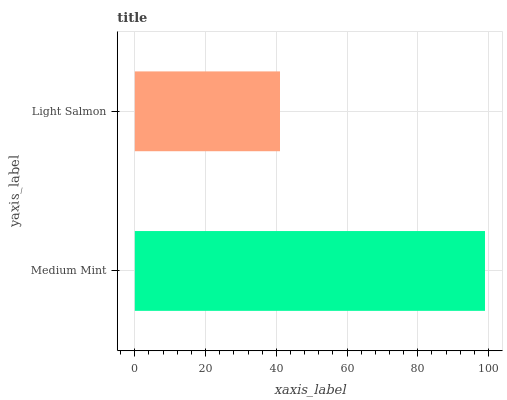Is Light Salmon the minimum?
Answer yes or no. Yes. Is Medium Mint the maximum?
Answer yes or no. Yes. Is Light Salmon the maximum?
Answer yes or no. No. Is Medium Mint greater than Light Salmon?
Answer yes or no. Yes. Is Light Salmon less than Medium Mint?
Answer yes or no. Yes. Is Light Salmon greater than Medium Mint?
Answer yes or no. No. Is Medium Mint less than Light Salmon?
Answer yes or no. No. Is Medium Mint the high median?
Answer yes or no. Yes. Is Light Salmon the low median?
Answer yes or no. Yes. Is Light Salmon the high median?
Answer yes or no. No. Is Medium Mint the low median?
Answer yes or no. No. 